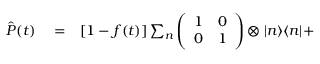Convert formula to latex. <formula><loc_0><loc_0><loc_500><loc_500>\begin{array} { r l r } { \hat { P } ( t ) } & = } & { [ 1 - f ( t ) ] \sum _ { n } \left ( \begin{array} { c c } { 1 } & { 0 } \\ { 0 } & { 1 } \end{array} \right ) \otimes | n \rangle \langle n | + } \end{array}</formula> 